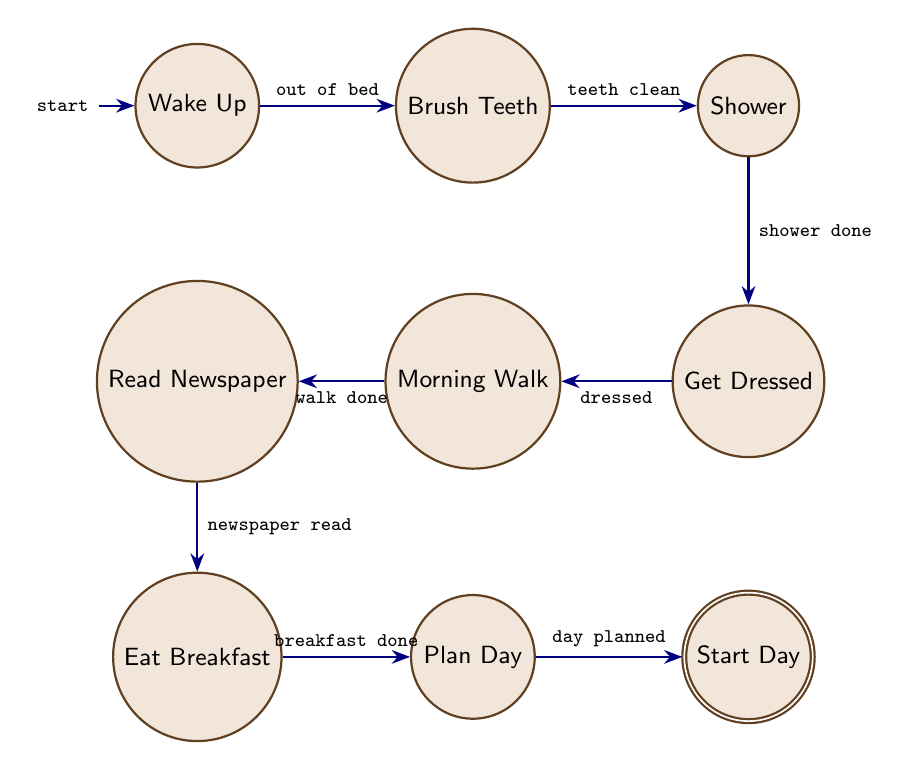What is the initial state in this diagram? The initial state is indicated in the diagram by the arrow pointing towards the "Wake Up" state. This shows that the process begins with waking up.
Answer: Wake Up How many states are there in total? Counting each unique state listed in the diagram, there are a total of 9 states: Wake Up, Brush Teeth, Shower, Get Dressed, Morning Walk, Read Newspaper, Eat Breakfast, Plan Day, and Start Day.
Answer: 9 What is the last activity before starting the day? By following the transitions from state to state, the last activity before "Start Day" is "Plan Day," as it directly leads to starting the day.
Answer: Plan Day Which activity follows brushing teeth? The transition from "Brush Teeth" to "Shower" shows that the next activity after brushing teeth is taking a shower.
Answer: Shower What is the condition required to move from "Eat Breakfast" to "Plan Day"? The condition that must be met to transition from "Eat Breakfast" to "Plan Day" is that breakfast needs to be completed. The transition specifies "breakfast done" as the condition.
Answer: breakfast done What are the states that involve personal preparation? The states that involve personal preparation are "Brush Teeth," "Shower," and "Get Dressed." These are all activities related to preparing oneself for the day.
Answer: Brush Teeth, Shower, Get Dressed What is the relationship between "Morning Walk" and "Read Newspaper"? The transition between "Morning Walk" and "Read Newspaper" indicates that after completing the morning walk, the next step is to read the newspaper. This illustrates a sequence of activities.
Answer: Morning Walk to Read Newspaper If the shower is done, which activity is performed next? After the condition of "shower done" is met, the next activity to be performed is "Get Dressed," as indicated by the transition in the diagram.
Answer: Get Dressed What are the conditions that must be met to start the day? To transition to "Start Day," the condition "day planned" must be met, meaning that all previous activities in the sequence have been completed satisfactorily.
Answer: day planned 